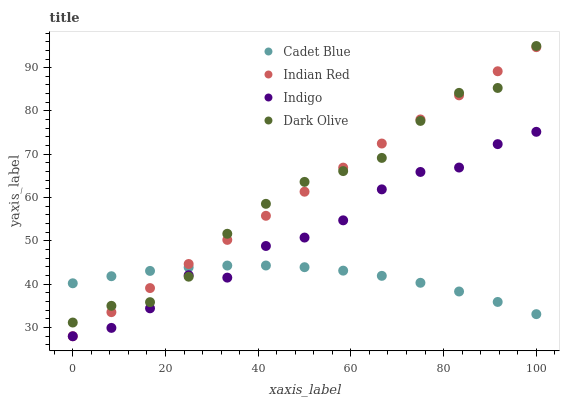Does Cadet Blue have the minimum area under the curve?
Answer yes or no. Yes. Does Indian Red have the maximum area under the curve?
Answer yes or no. Yes. Does Indigo have the minimum area under the curve?
Answer yes or no. No. Does Indigo have the maximum area under the curve?
Answer yes or no. No. Is Indian Red the smoothest?
Answer yes or no. Yes. Is Indigo the roughest?
Answer yes or no. Yes. Is Cadet Blue the smoothest?
Answer yes or no. No. Is Cadet Blue the roughest?
Answer yes or no. No. Does Indigo have the lowest value?
Answer yes or no. Yes. Does Cadet Blue have the lowest value?
Answer yes or no. No. Does Dark Olive have the highest value?
Answer yes or no. Yes. Does Indigo have the highest value?
Answer yes or no. No. Does Dark Olive intersect Indigo?
Answer yes or no. Yes. Is Dark Olive less than Indigo?
Answer yes or no. No. Is Dark Olive greater than Indigo?
Answer yes or no. No. 